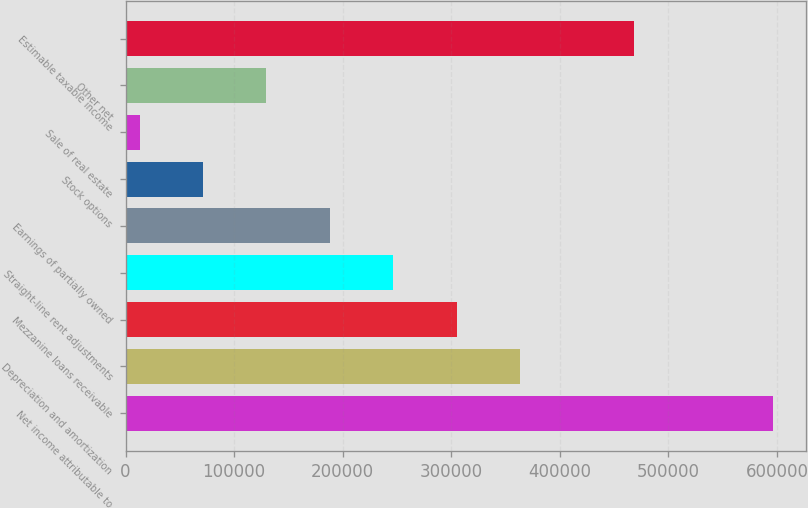<chart> <loc_0><loc_0><loc_500><loc_500><bar_chart><fcel>Net income attributable to<fcel>Depreciation and amortization<fcel>Mezzanine loans receivable<fcel>Straight-line rent adjustments<fcel>Earnings of partially owned<fcel>Stock options<fcel>Sale of real estate<fcel>Other net<fcel>Estimable taxable income<nl><fcel>596731<fcel>363198<fcel>304815<fcel>246432<fcel>188049<fcel>71282.2<fcel>12899<fcel>129665<fcel>467851<nl></chart> 